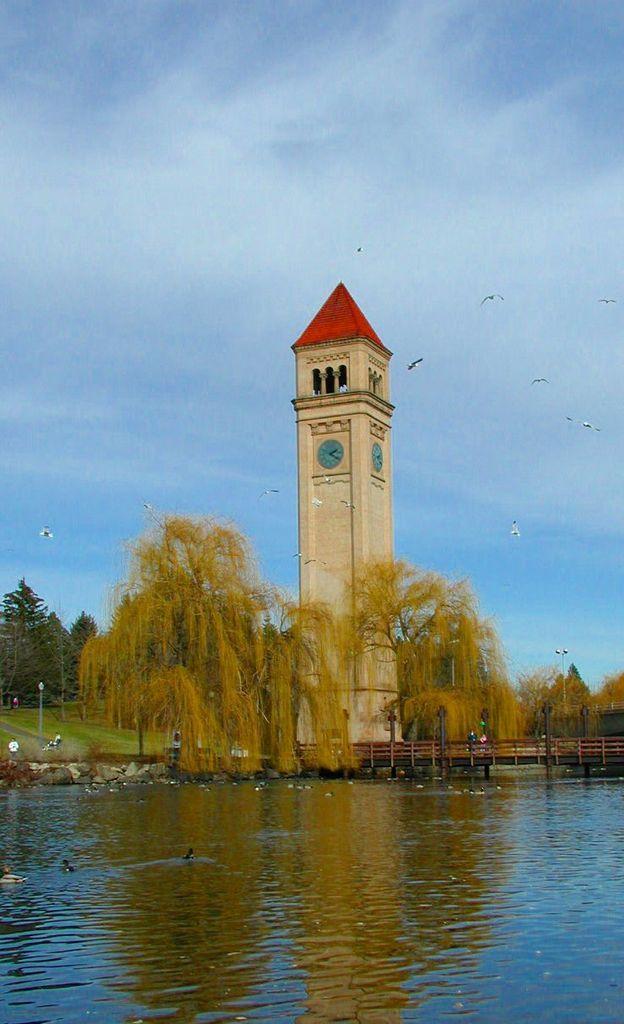Please provide a concise description of this image. There are birds swimming in the water. In the background, there is a bridge on the water, there are trees and grass on the ground, there is a tower on which there are clocks, there are birds flying in the air and there are clouds in the blue sky. 